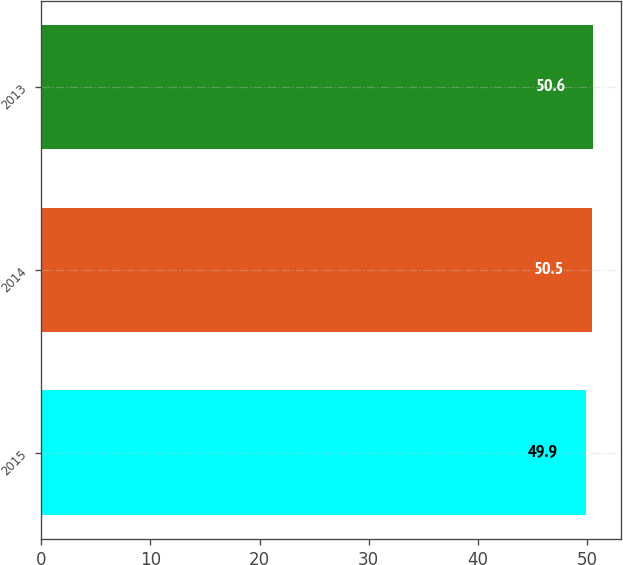<chart> <loc_0><loc_0><loc_500><loc_500><bar_chart><fcel>2015<fcel>2014<fcel>2013<nl><fcel>49.9<fcel>50.5<fcel>50.6<nl></chart> 